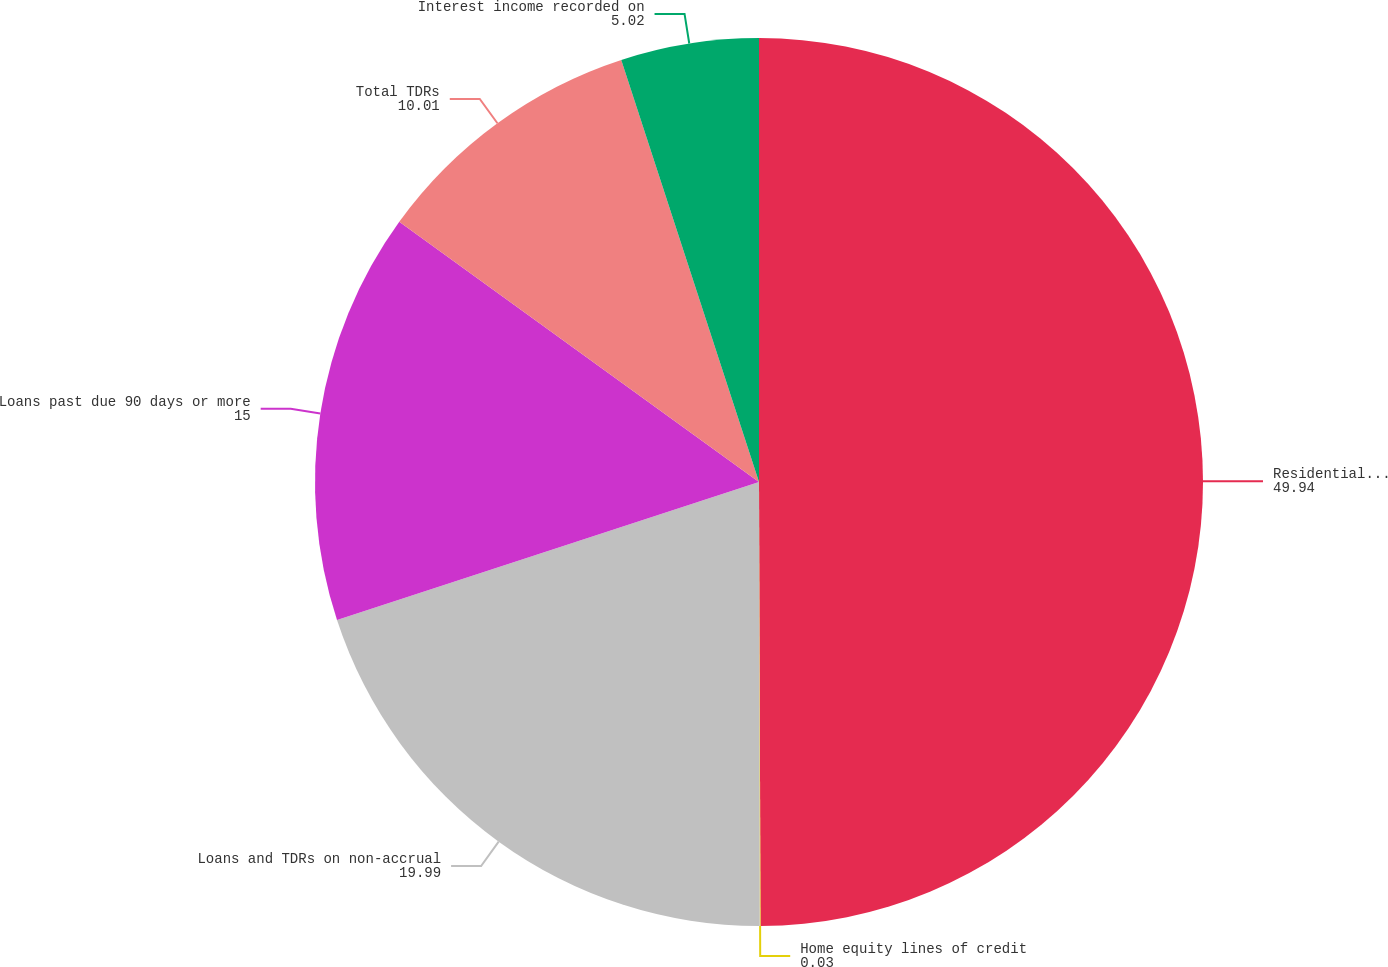Convert chart. <chart><loc_0><loc_0><loc_500><loc_500><pie_chart><fcel>Residential real estate<fcel>Home equity lines of credit<fcel>Loans and TDRs on non-accrual<fcel>Loans past due 90 days or more<fcel>Total TDRs<fcel>Interest income recorded on<nl><fcel>49.94%<fcel>0.03%<fcel>19.99%<fcel>15.0%<fcel>10.01%<fcel>5.02%<nl></chart> 